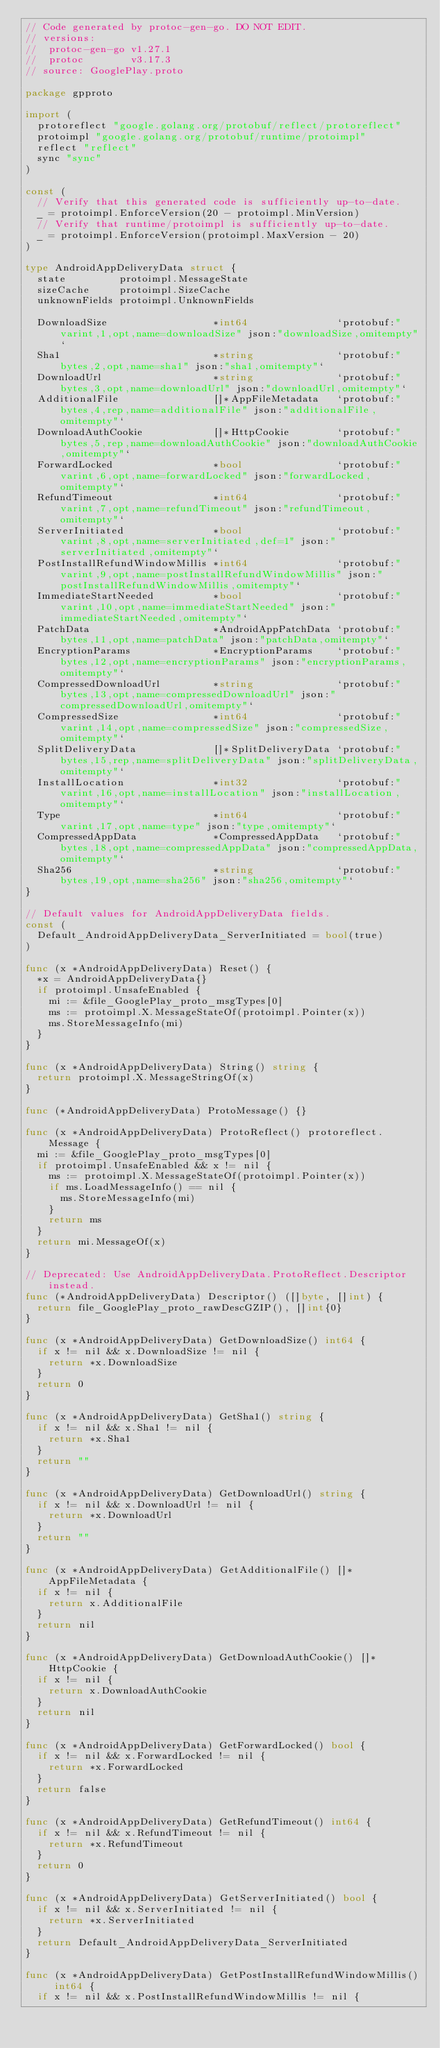<code> <loc_0><loc_0><loc_500><loc_500><_Go_>// Code generated by protoc-gen-go. DO NOT EDIT.
// versions:
// 	protoc-gen-go v1.27.1
// 	protoc        v3.17.3
// source: GooglePlay.proto

package gpproto

import (
	protoreflect "google.golang.org/protobuf/reflect/protoreflect"
	protoimpl "google.golang.org/protobuf/runtime/protoimpl"
	reflect "reflect"
	sync "sync"
)

const (
	// Verify that this generated code is sufficiently up-to-date.
	_ = protoimpl.EnforceVersion(20 - protoimpl.MinVersion)
	// Verify that runtime/protoimpl is sufficiently up-to-date.
	_ = protoimpl.EnforceVersion(protoimpl.MaxVersion - 20)
)

type AndroidAppDeliveryData struct {
	state         protoimpl.MessageState
	sizeCache     protoimpl.SizeCache
	unknownFields protoimpl.UnknownFields

	DownloadSize                  *int64               `protobuf:"varint,1,opt,name=downloadSize" json:"downloadSize,omitempty"`
	Sha1                          *string              `protobuf:"bytes,2,opt,name=sha1" json:"sha1,omitempty"`
	DownloadUrl                   *string              `protobuf:"bytes,3,opt,name=downloadUrl" json:"downloadUrl,omitempty"`
	AdditionalFile                []*AppFileMetadata   `protobuf:"bytes,4,rep,name=additionalFile" json:"additionalFile,omitempty"`
	DownloadAuthCookie            []*HttpCookie        `protobuf:"bytes,5,rep,name=downloadAuthCookie" json:"downloadAuthCookie,omitempty"`
	ForwardLocked                 *bool                `protobuf:"varint,6,opt,name=forwardLocked" json:"forwardLocked,omitempty"`
	RefundTimeout                 *int64               `protobuf:"varint,7,opt,name=refundTimeout" json:"refundTimeout,omitempty"`
	ServerInitiated               *bool                `protobuf:"varint,8,opt,name=serverInitiated,def=1" json:"serverInitiated,omitempty"`
	PostInstallRefundWindowMillis *int64               `protobuf:"varint,9,opt,name=postInstallRefundWindowMillis" json:"postInstallRefundWindowMillis,omitempty"`
	ImmediateStartNeeded          *bool                `protobuf:"varint,10,opt,name=immediateStartNeeded" json:"immediateStartNeeded,omitempty"`
	PatchData                     *AndroidAppPatchData `protobuf:"bytes,11,opt,name=patchData" json:"patchData,omitempty"`
	EncryptionParams              *EncryptionParams    `protobuf:"bytes,12,opt,name=encryptionParams" json:"encryptionParams,omitempty"`
	CompressedDownloadUrl         *string              `protobuf:"bytes,13,opt,name=compressedDownloadUrl" json:"compressedDownloadUrl,omitempty"`
	CompressedSize                *int64               `protobuf:"varint,14,opt,name=compressedSize" json:"compressedSize,omitempty"`
	SplitDeliveryData             []*SplitDeliveryData `protobuf:"bytes,15,rep,name=splitDeliveryData" json:"splitDeliveryData,omitempty"`
	InstallLocation               *int32               `protobuf:"varint,16,opt,name=installLocation" json:"installLocation,omitempty"`
	Type                          *int64               `protobuf:"varint,17,opt,name=type" json:"type,omitempty"`
	CompressedAppData             *CompressedAppData   `protobuf:"bytes,18,opt,name=compressedAppData" json:"compressedAppData,omitempty"`
	Sha256                        *string              `protobuf:"bytes,19,opt,name=sha256" json:"sha256,omitempty"`
}

// Default values for AndroidAppDeliveryData fields.
const (
	Default_AndroidAppDeliveryData_ServerInitiated = bool(true)
)

func (x *AndroidAppDeliveryData) Reset() {
	*x = AndroidAppDeliveryData{}
	if protoimpl.UnsafeEnabled {
		mi := &file_GooglePlay_proto_msgTypes[0]
		ms := protoimpl.X.MessageStateOf(protoimpl.Pointer(x))
		ms.StoreMessageInfo(mi)
	}
}

func (x *AndroidAppDeliveryData) String() string {
	return protoimpl.X.MessageStringOf(x)
}

func (*AndroidAppDeliveryData) ProtoMessage() {}

func (x *AndroidAppDeliveryData) ProtoReflect() protoreflect.Message {
	mi := &file_GooglePlay_proto_msgTypes[0]
	if protoimpl.UnsafeEnabled && x != nil {
		ms := protoimpl.X.MessageStateOf(protoimpl.Pointer(x))
		if ms.LoadMessageInfo() == nil {
			ms.StoreMessageInfo(mi)
		}
		return ms
	}
	return mi.MessageOf(x)
}

// Deprecated: Use AndroidAppDeliveryData.ProtoReflect.Descriptor instead.
func (*AndroidAppDeliveryData) Descriptor() ([]byte, []int) {
	return file_GooglePlay_proto_rawDescGZIP(), []int{0}
}

func (x *AndroidAppDeliveryData) GetDownloadSize() int64 {
	if x != nil && x.DownloadSize != nil {
		return *x.DownloadSize
	}
	return 0
}

func (x *AndroidAppDeliveryData) GetSha1() string {
	if x != nil && x.Sha1 != nil {
		return *x.Sha1
	}
	return ""
}

func (x *AndroidAppDeliveryData) GetDownloadUrl() string {
	if x != nil && x.DownloadUrl != nil {
		return *x.DownloadUrl
	}
	return ""
}

func (x *AndroidAppDeliveryData) GetAdditionalFile() []*AppFileMetadata {
	if x != nil {
		return x.AdditionalFile
	}
	return nil
}

func (x *AndroidAppDeliveryData) GetDownloadAuthCookie() []*HttpCookie {
	if x != nil {
		return x.DownloadAuthCookie
	}
	return nil
}

func (x *AndroidAppDeliveryData) GetForwardLocked() bool {
	if x != nil && x.ForwardLocked != nil {
		return *x.ForwardLocked
	}
	return false
}

func (x *AndroidAppDeliveryData) GetRefundTimeout() int64 {
	if x != nil && x.RefundTimeout != nil {
		return *x.RefundTimeout
	}
	return 0
}

func (x *AndroidAppDeliveryData) GetServerInitiated() bool {
	if x != nil && x.ServerInitiated != nil {
		return *x.ServerInitiated
	}
	return Default_AndroidAppDeliveryData_ServerInitiated
}

func (x *AndroidAppDeliveryData) GetPostInstallRefundWindowMillis() int64 {
	if x != nil && x.PostInstallRefundWindowMillis != nil {</code> 